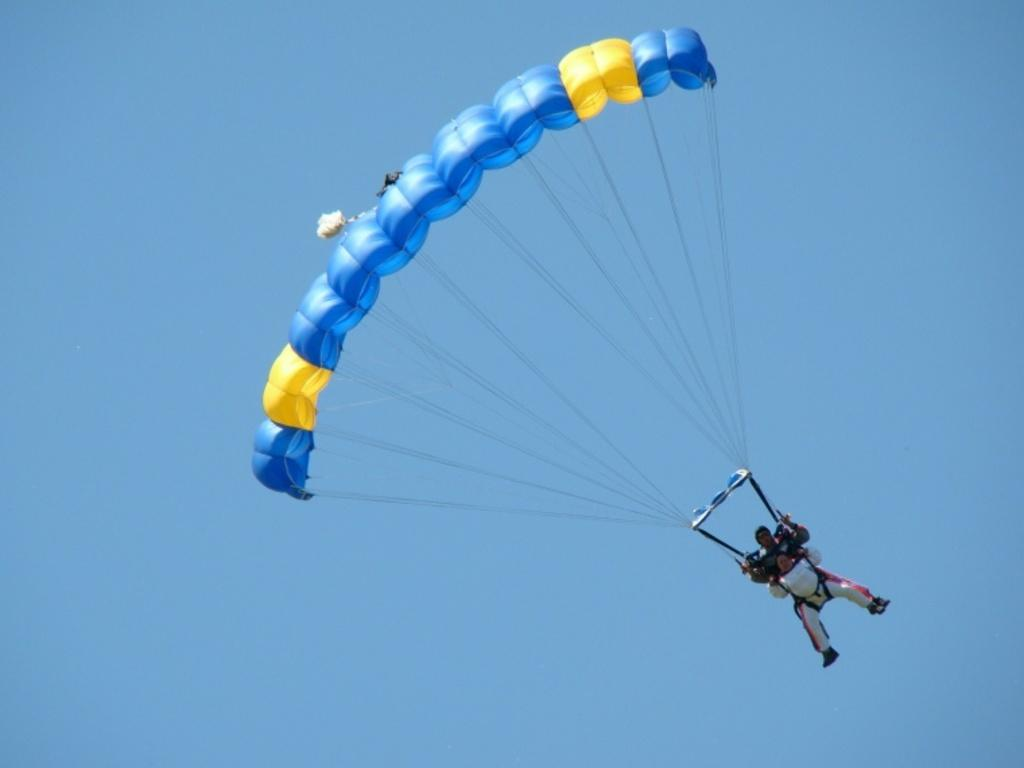What is happening to the person in the image? The person is flying in the air. How is the person flying in the air? The person is using a parachute. What colors can be seen on the parachute? The parachute has blue and yellow colors. What is visible in the background of the image? The sky is visible in the background of the image. What is the color of the sky in the image? The sky is blue in color. What type of zinc is being used to hold the parachute in place in the image? There is no zinc present in the image; the person is using a parachute to fly in the air. What is the person's emotional state while flying in the image? The image does not provide information about the person's emotional state, so it cannot be determined. 